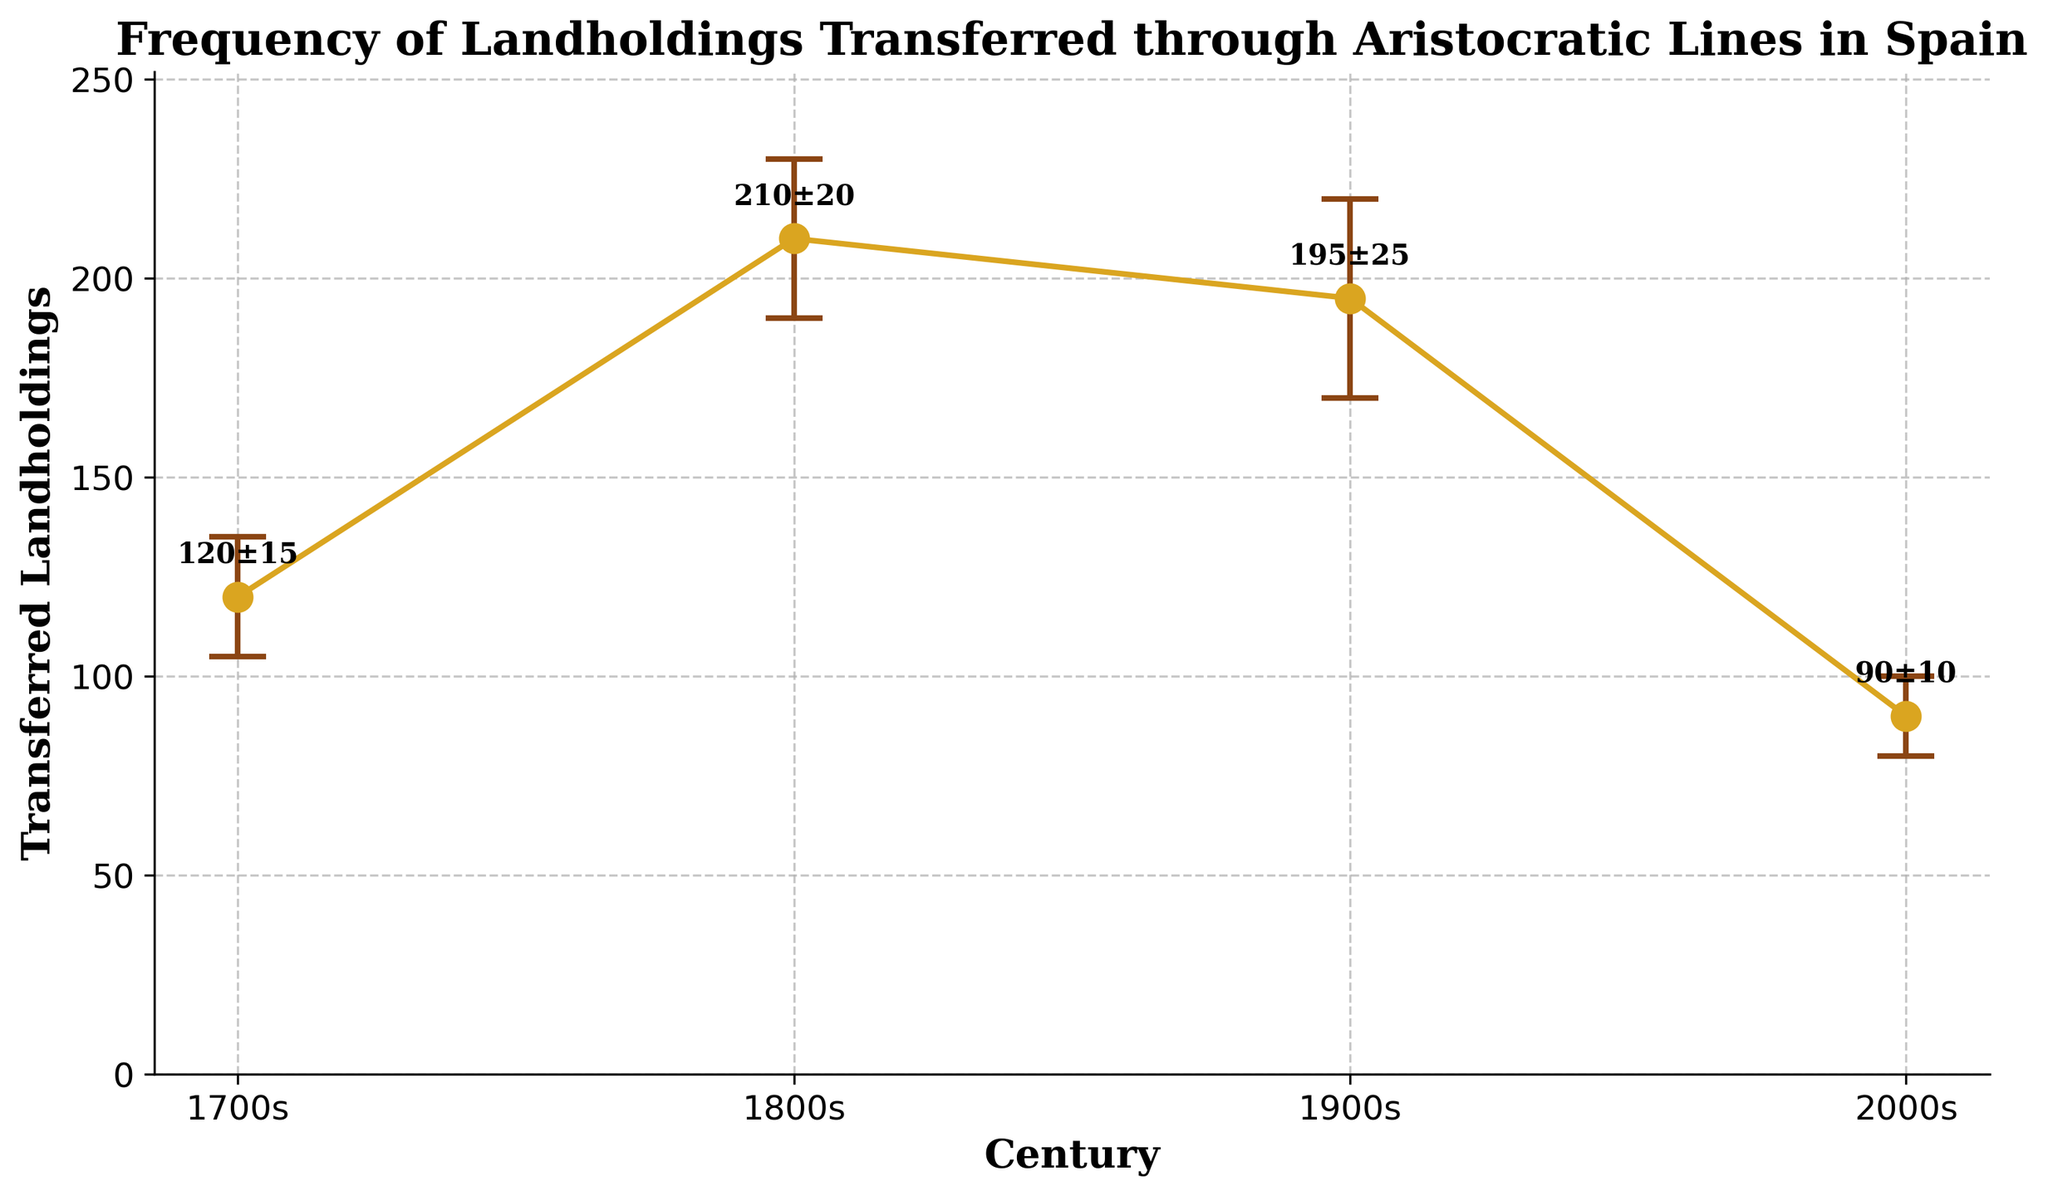How many centuries are represented in the plot? The x-axis labels represent different centuries, and there are four distinct marks indicating the time periods.
Answer: 4 What is the transferred landholdings value for the 1900s? The plot shows a data point for 1900s with a label indicating the frequency of transferred landholding.
Answer: 195 Which century has the highest frequency of transferred landholdings? By comparing the y-values of the data points, the 1800s has the highest peak in the plot at 210.
Answer: 1800s What is the average frequency of transferred landholdings across all centuries shown? First, sum up the frequencies: 120 (1700s) + 210 (1800s) + 195 (1900s) + 90 (2000s) = 615. Then, divide by the number of centuries (4): 615 / 4 = 153.75
Answer: 153.75 Which century shows the lowest frequency of transferred landholdings? By comparing the y-values, the 2000s has the lowest point at 90.
Answer: 2000s What is the difference in frequency of transferred landholdings between the 2000s and 1700s? The frequency for 2000s is 90, and for 1700s it is 120. Subtracting these gives: 120 - 90 = 30
Answer: 30 How much did the frequency of transferred landholdings increase from the 1700s to the 1800s? The frequency in the 1700s is 120 and in the 1800s is 210. The increase is 210 - 120 = 90
Answer: 90 Which century has the largest error bar, indicating the most ambiguous inheritances or losses? By looking at the length of the error bars, the 1900s has the largest error bar of ±25.
Answer: 1900s Between which centuries do we see a decrease in the frequency of transferred landholdings? Compare frequency values between consecutive centuries: There is a decrease from the 1800s (210) to the 1900s (195), and another from the 1900s (195) to the 2000s (90).
Answer: 1800s to 1900s, 1900s to 2000s What trend can be observed in the frequency of transferred landholdings from the 1800s onwards? The trend shows an initial peak in the 1800s, followed by a decrease in the 1900s, and a further drop in the 2000s.
Answer: Decreasing trend 